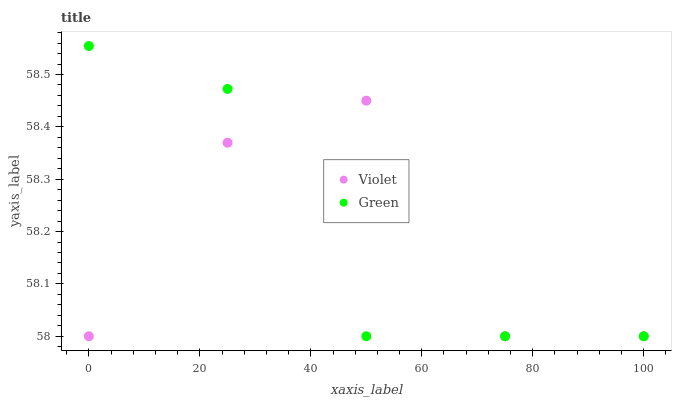Does Green have the minimum area under the curve?
Answer yes or no. Yes. Does Violet have the maximum area under the curve?
Answer yes or no. Yes. Does Violet have the minimum area under the curve?
Answer yes or no. No. Is Green the smoothest?
Answer yes or no. Yes. Is Violet the roughest?
Answer yes or no. Yes. Is Violet the smoothest?
Answer yes or no. No. Does Green have the lowest value?
Answer yes or no. Yes. Does Green have the highest value?
Answer yes or no. Yes. Does Violet have the highest value?
Answer yes or no. No. Does Violet intersect Green?
Answer yes or no. Yes. Is Violet less than Green?
Answer yes or no. No. Is Violet greater than Green?
Answer yes or no. No. 